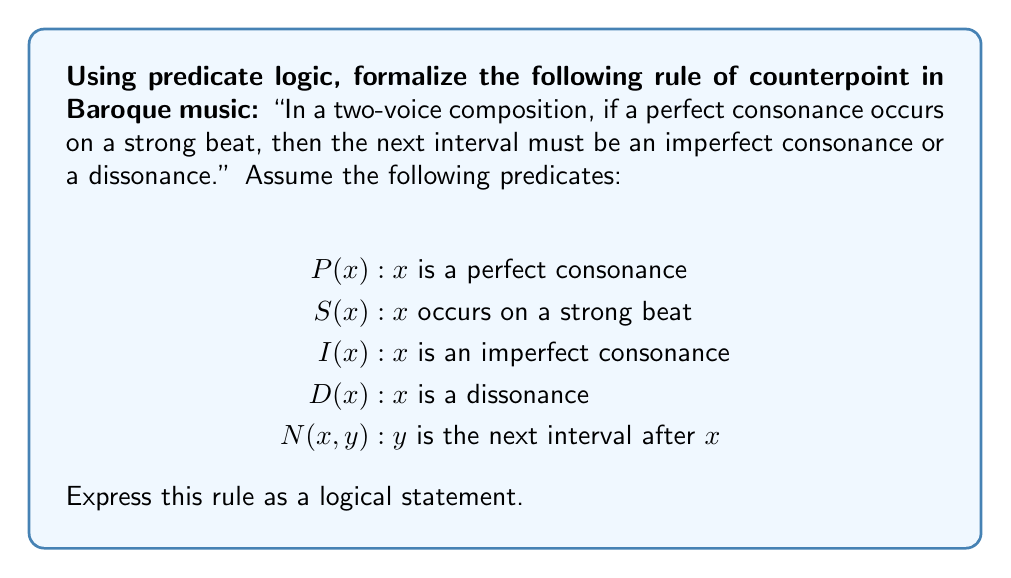What is the answer to this math problem? To formalize this rule using predicate logic, we need to break it down into its components and translate them into logical statements:

1. "If a perfect consonance occurs on a strong beat" can be expressed as:
   $P(x) \land S(x)$

2. "Then the next interval must be an imperfect consonance or a dissonance" can be expressed as:
   $\exists y(N(x,y) \land (I(y) \lor D(y)))$

3. We need to connect these two parts with an implication:
   $(P(x) \land S(x)) \rightarrow \exists y(N(x,y) \land (I(y) \lor D(y)))$

4. Finally, we need to quantify this statement for all intervals x:
   $\forall x((P(x) \land S(x)) \rightarrow \exists y(N(x,y) \land (I(y) \lor D(y))))$

This logical statement can be read as: "For all intervals x, if x is a perfect consonance and occurs on a strong beat, then there exists an interval y such that y is the next interval after x, and y is either an imperfect consonance or a dissonance."

This formalization captures the essence of the counterpoint rule, expressing it in a precise mathematical language that can be used for further analysis or computational applications in music theory.
Answer: $$\forall x((P(x) \land S(x)) \rightarrow \exists y(N(x,y) \land (I(y) \lor D(y))))$$ 